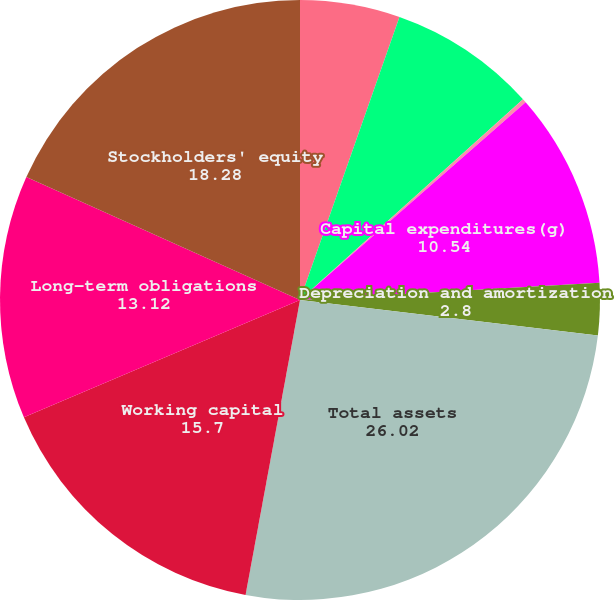Convert chart. <chart><loc_0><loc_0><loc_500><loc_500><pie_chart><fcel>Net cash provided by operating<fcel>Net cash used in investing<fcel>Net cash provided by (used in)<fcel>Capital expenditures(g)<fcel>Depreciation and amortization<fcel>Total assets<fcel>Working capital<fcel>Long-term obligations<fcel>Stockholders' equity<nl><fcel>5.38%<fcel>7.96%<fcel>0.21%<fcel>10.54%<fcel>2.8%<fcel>26.02%<fcel>15.7%<fcel>13.12%<fcel>18.28%<nl></chart> 